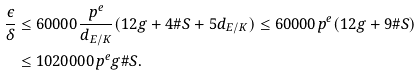Convert formula to latex. <formula><loc_0><loc_0><loc_500><loc_500>\frac { \epsilon } { \delta } & \leq 6 0 0 0 0 \frac { p ^ { e } } { d _ { E / K } } ( 1 2 g + 4 \# S + 5 d _ { E / K } ) \leq 6 0 0 0 0 p ^ { e } ( 1 2 g + 9 \# S ) \\ & \leq 1 0 2 0 0 0 0 p ^ { e } g \# S .</formula> 